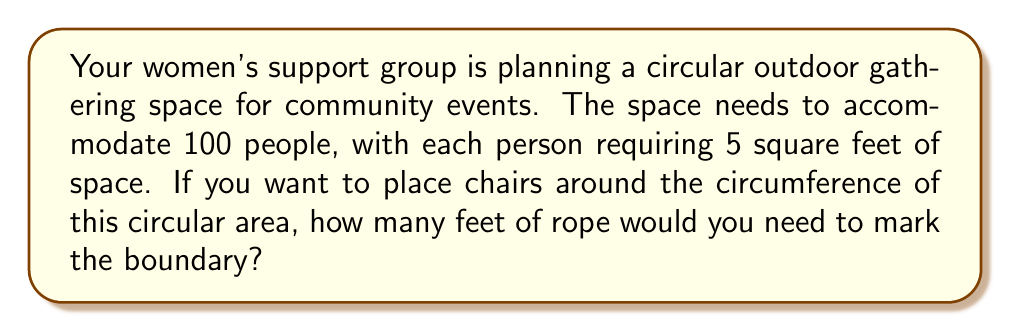Could you help me with this problem? Let's approach this step-by-step:

1) First, we need to calculate the total area required:
   $$ \text{Total Area} = 100 \text{ people} \times 5 \text{ sq ft/person} = 500 \text{ sq ft} $$

2) Now, we know that the area of a circle is given by the formula:
   $$ A = \pi r^2 $$
   where $A$ is the area and $r$ is the radius.

3) We can rearrange this to solve for $r$:
   $$ r = \sqrt{\frac{A}{\pi}} $$

4) Plugging in our area:
   $$ r = \sqrt{\frac{500}{\pi}} \approx 12.62 \text{ ft} $$

5) Now that we have the radius, we can calculate the circumference using the formula:
   $$ C = 2\pi r $$

6) Substituting our radius:
   $$ C = 2\pi(12.62) \approx 79.27 \text{ ft} $$

Therefore, you would need approximately 79.27 feet of rope to mark the boundary of the circular gathering space.

[asy]
unitsize(1cm);
draw(circle((0,0),4), blue);
label("r = 12.62 ft", (2,0), E);
label("C ≈ 79.27 ft", (0,4.5), N);
[/asy]
Answer: The amount of rope needed to mark the boundary of the circular gathering space is approximately 79.27 feet. 